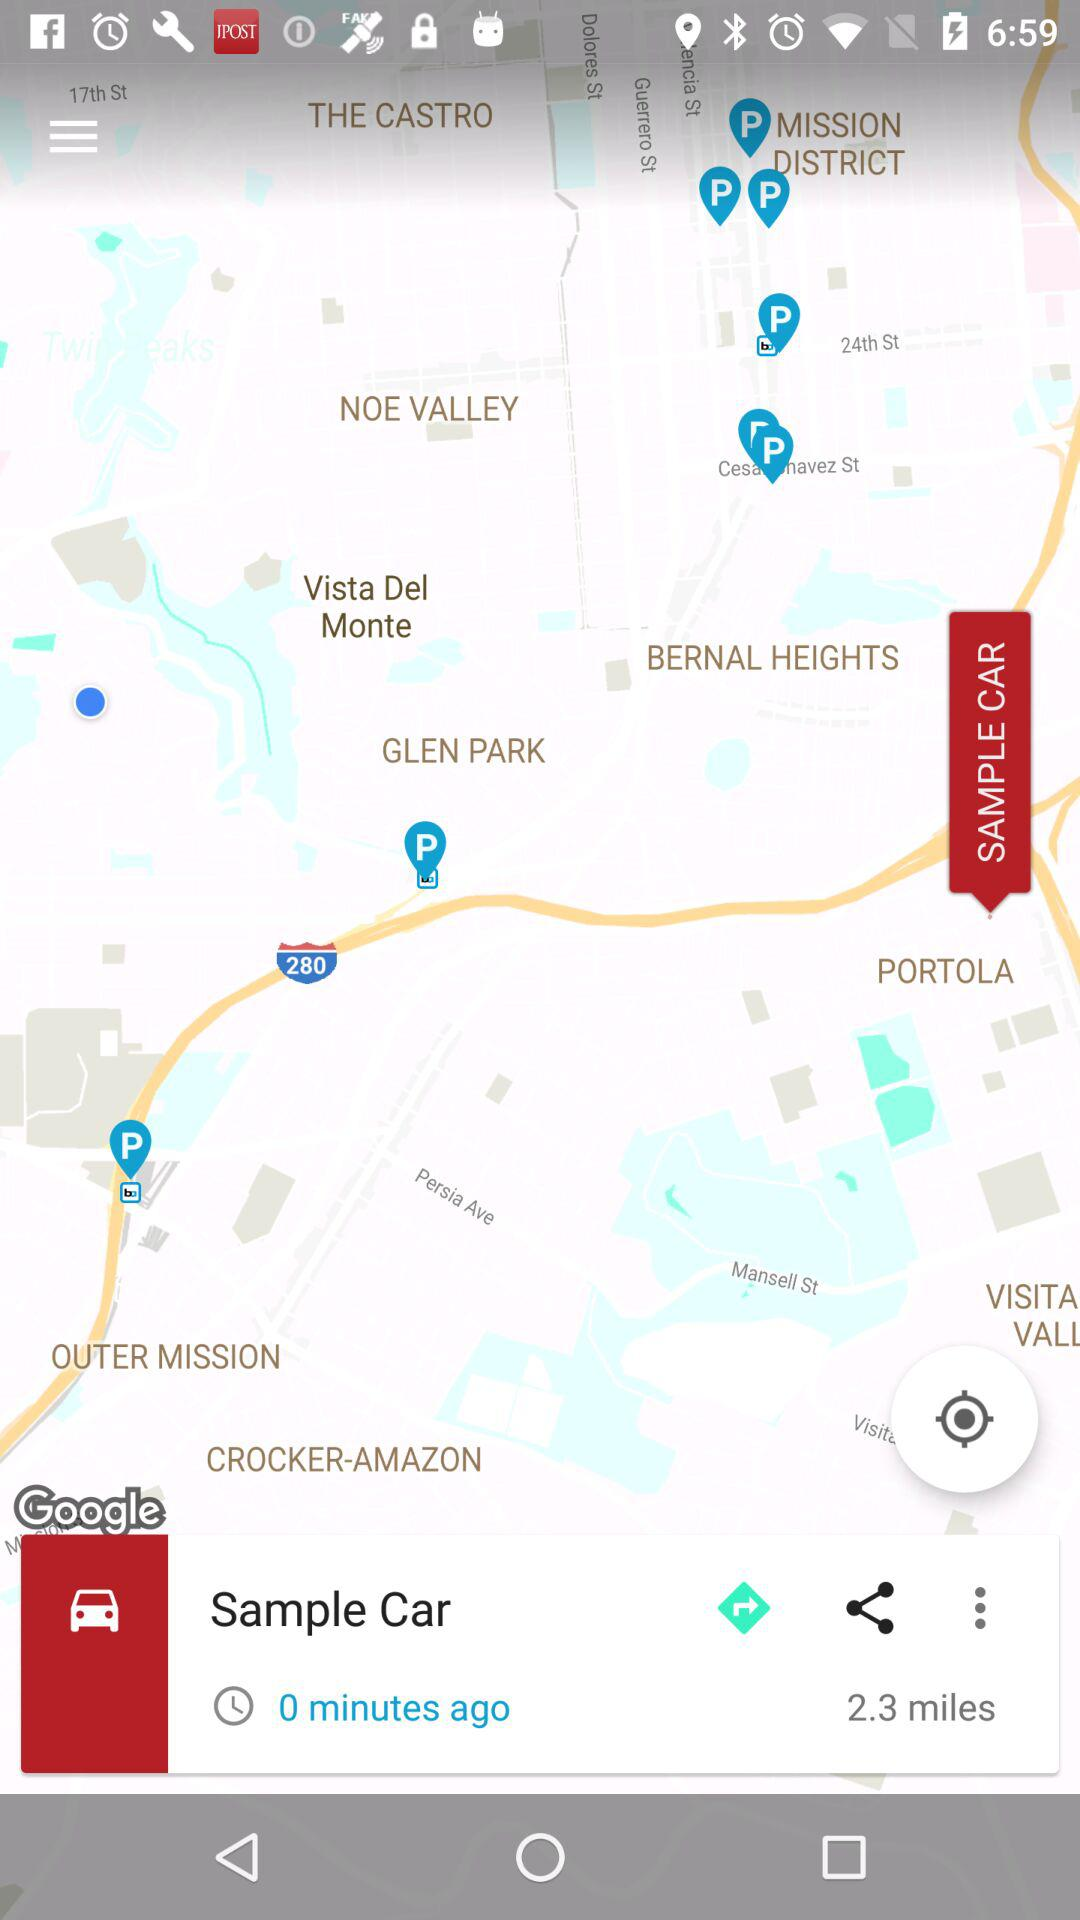How many miles are shown on the "Sample Car"? The miles shown on the "Sample Car" are 2.3. 